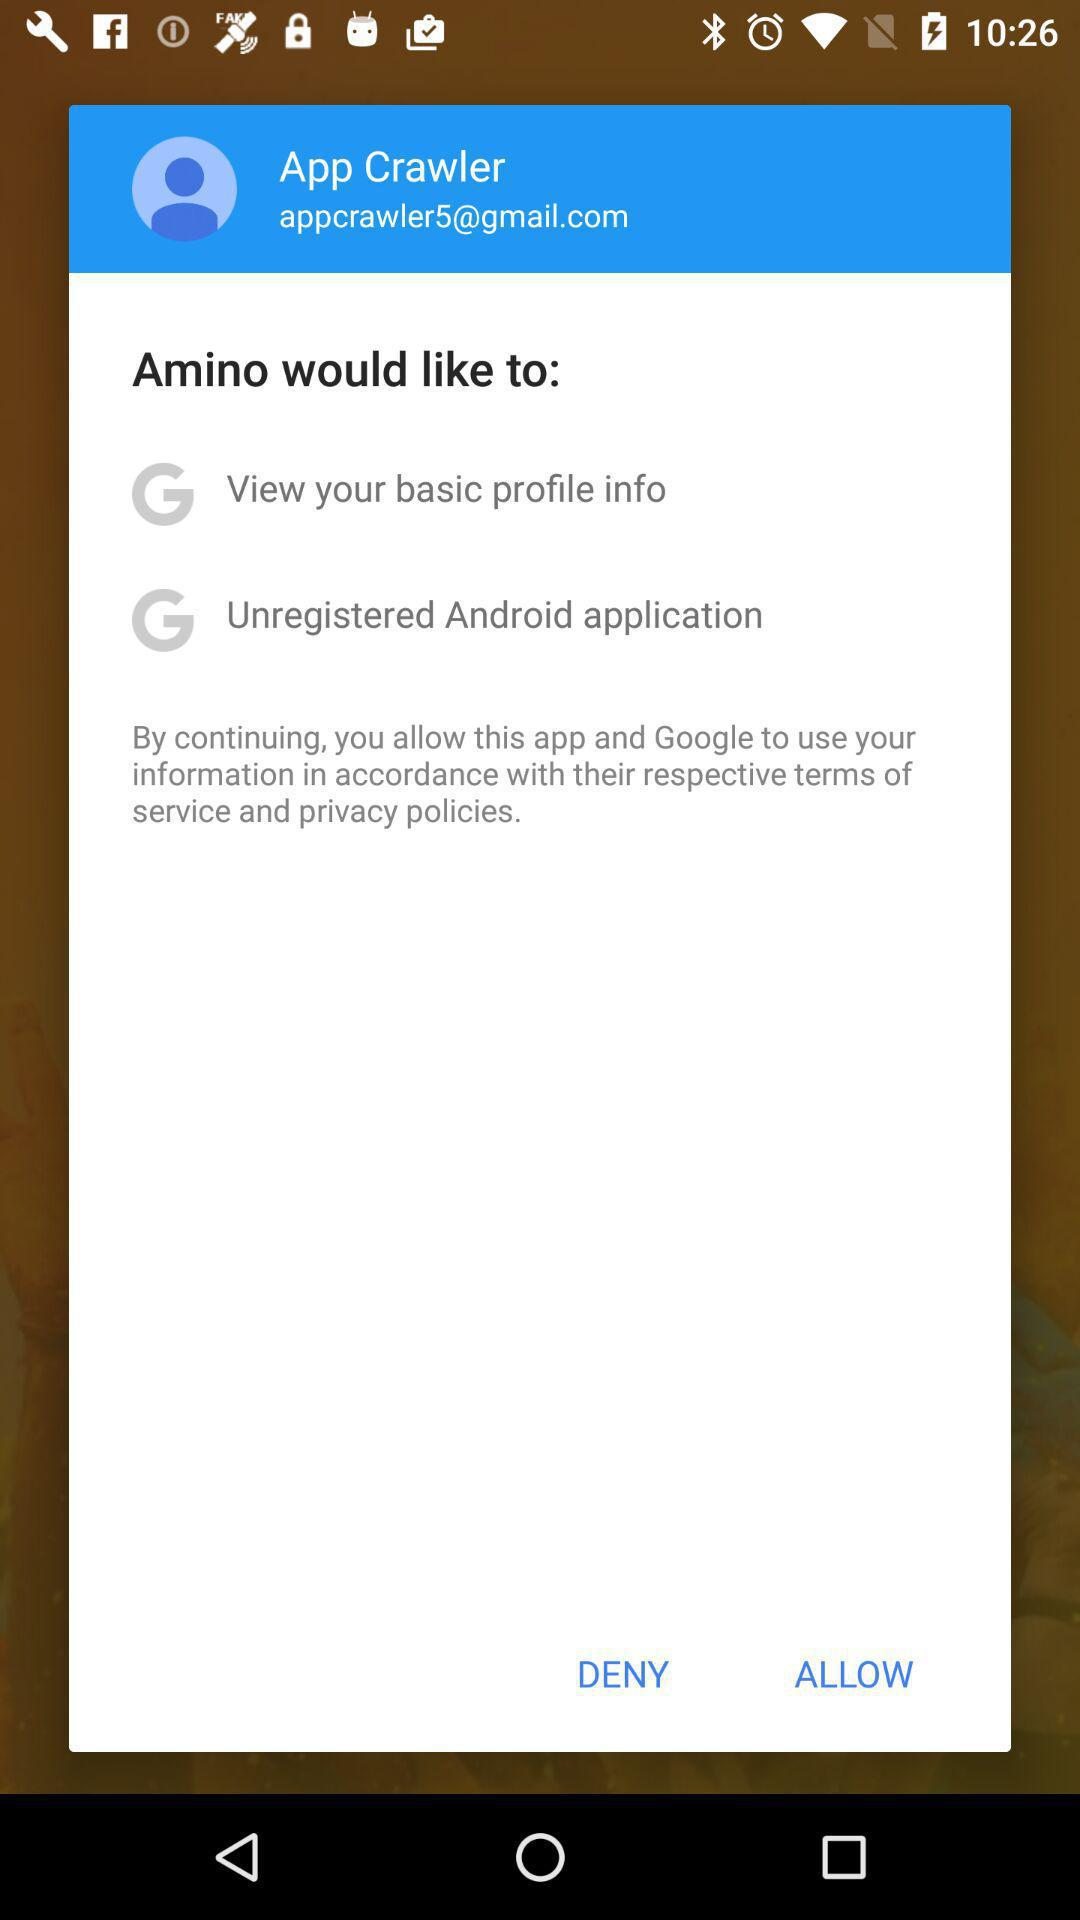What is the name of the user? The name of the user is App Crawler. 